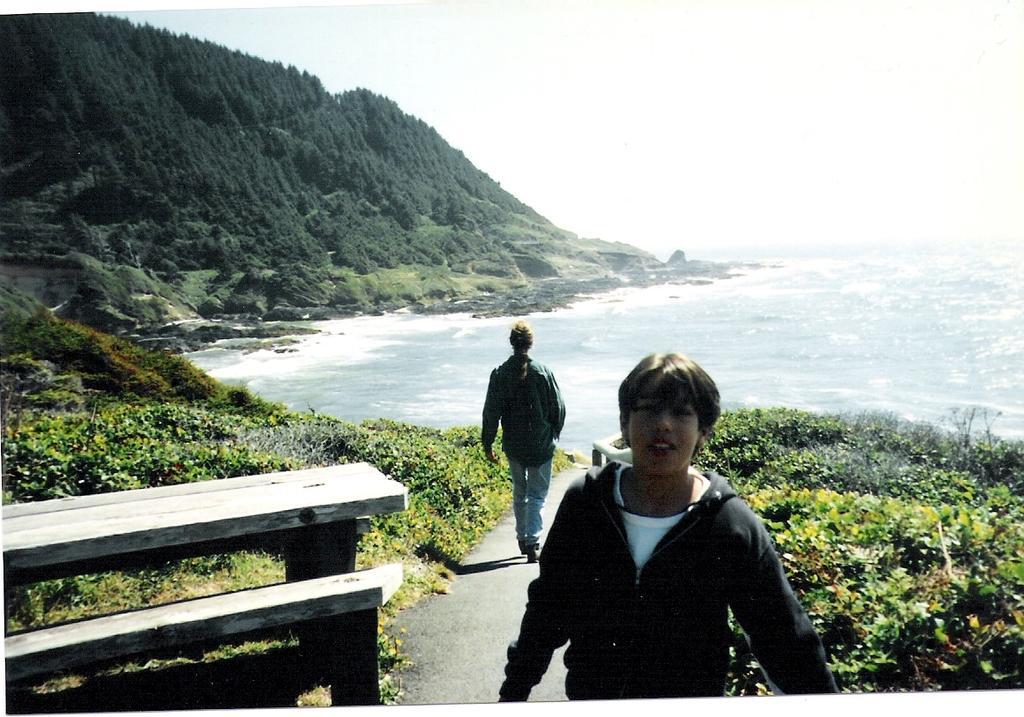Could you give a brief overview of what you see in this image? In this image there is a person standing and staring at the camera, behind him there is another person walking down the road, on the either side of the road there is grass, in front of the image there is a wooden bench, in the background of the image there is water and mountains. 